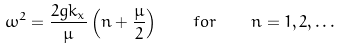Convert formula to latex. <formula><loc_0><loc_0><loc_500><loc_500>\omega ^ { 2 } = \frac { 2 g k _ { x } } { \mu } \left ( n + \frac { \mu } { 2 } \right ) \quad f o r \quad n = 1 , 2 , \dots</formula> 